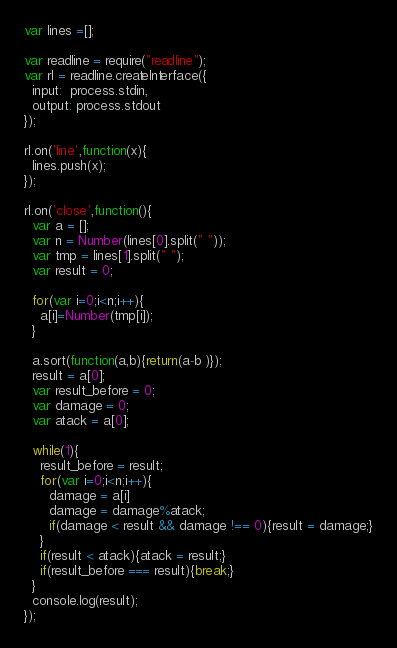<code> <loc_0><loc_0><loc_500><loc_500><_JavaScript_>var lines =[];

var readline = require("readline");
var rl = readline.createInterface({
  input:  process.stdin,
  output: process.stdout
});

rl.on('line',function(x){
  lines.push(x);
});

rl.on('close',function(){
  var a = [];
  var n = Number(lines[0].split(" "));
  var tmp = lines[1].split(" ");
  var result = 0;

  for(var i=0;i<n;i++){
    a[i]=Number(tmp[i]);
  }

  a.sort(function(a,b){return(a-b )});
  result = a[0];
  var result_before = 0;
  var damage = 0;
  var atack = a[0];

  while(1){
    result_before = result;
    for(var i=0;i<n;i++){
      damage = a[i]
      damage = damage%atack;
      if(damage < result && damage !== 0){result = damage;}
    }
    if(result < atack){atack = result;}
    if(result_before === result){break;}
  }
  console.log(result);
});
</code> 